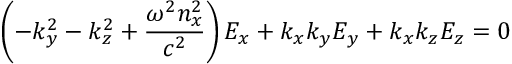Convert formula to latex. <formula><loc_0><loc_0><loc_500><loc_500>\left ( - k _ { y } ^ { 2 } - k _ { z } ^ { 2 } + { \frac { \omega ^ { 2 } n _ { x } ^ { 2 } } { c ^ { 2 } } } \right ) E _ { x } + k _ { x } k _ { y } E _ { y } + k _ { x } k _ { z } E _ { z } = 0</formula> 